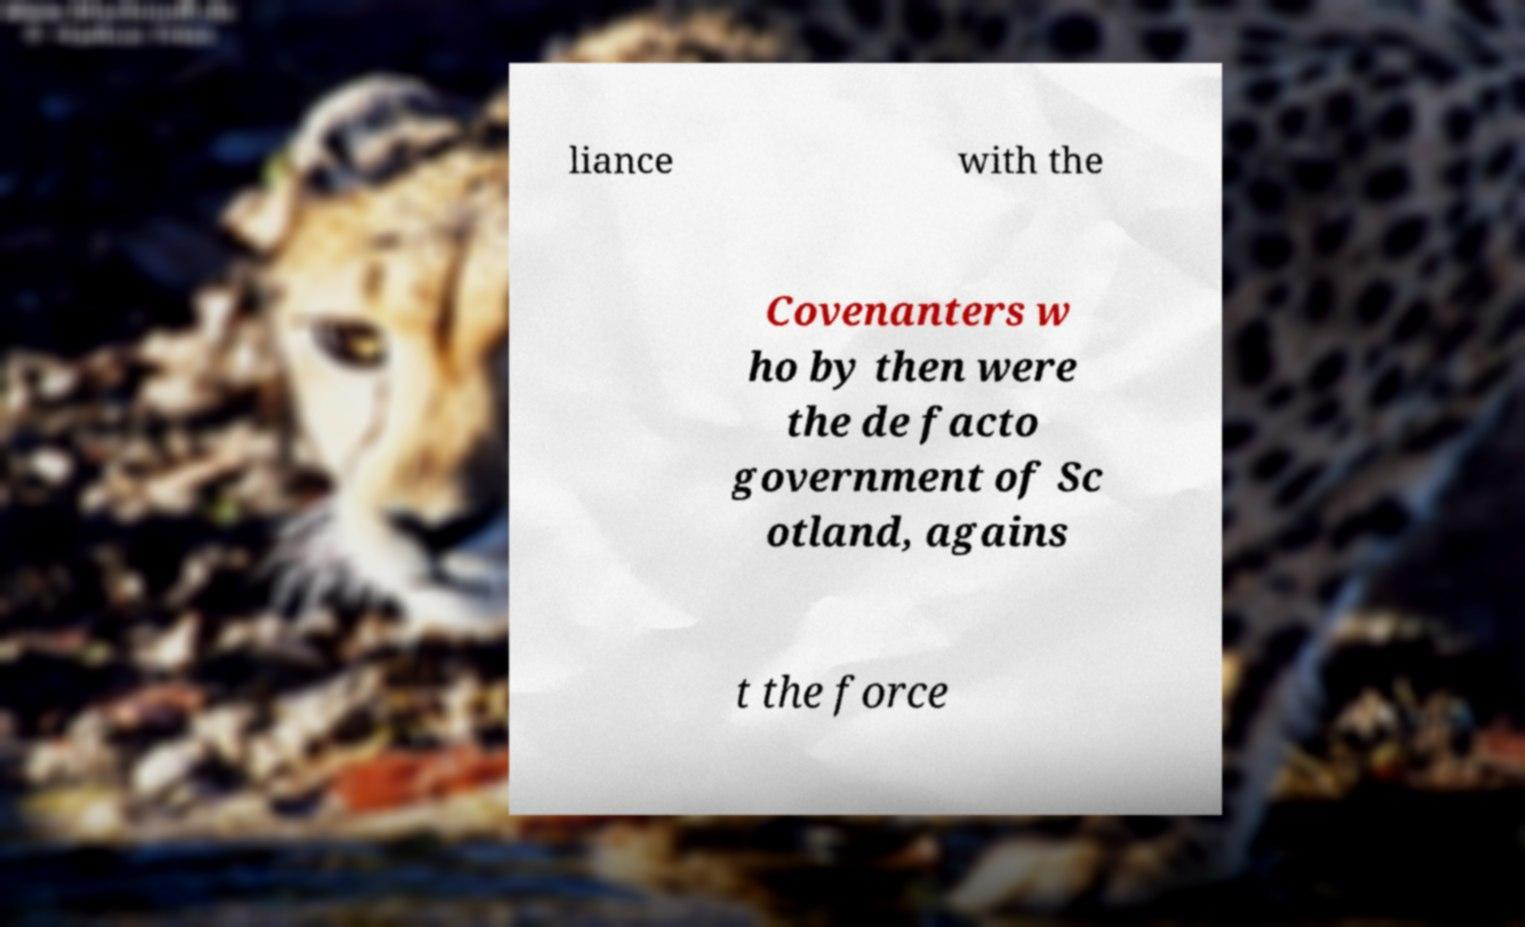I need the written content from this picture converted into text. Can you do that? liance with the Covenanters w ho by then were the de facto government of Sc otland, agains t the force 